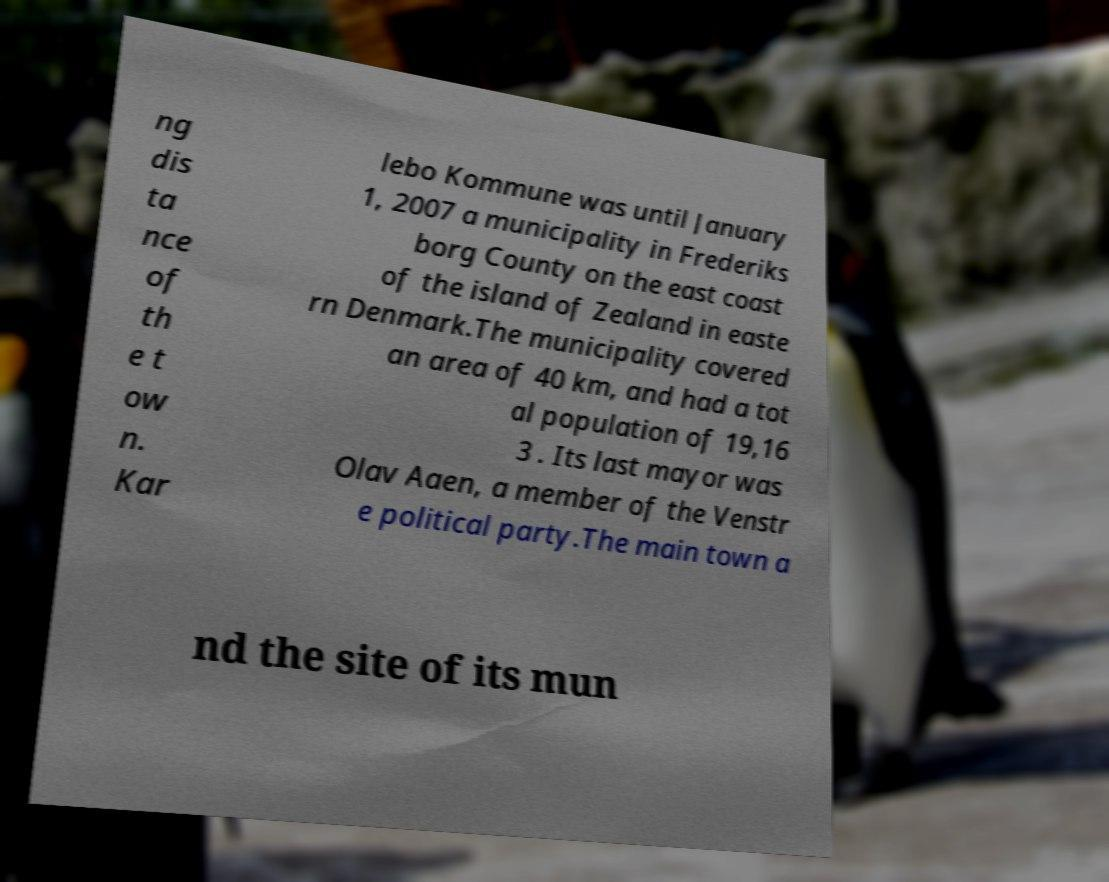Could you assist in decoding the text presented in this image and type it out clearly? ng dis ta nce of th e t ow n. Kar lebo Kommune was until January 1, 2007 a municipality in Frederiks borg County on the east coast of the island of Zealand in easte rn Denmark.The municipality covered an area of 40 km, and had a tot al population of 19,16 3 . Its last mayor was Olav Aaen, a member of the Venstr e political party.The main town a nd the site of its mun 